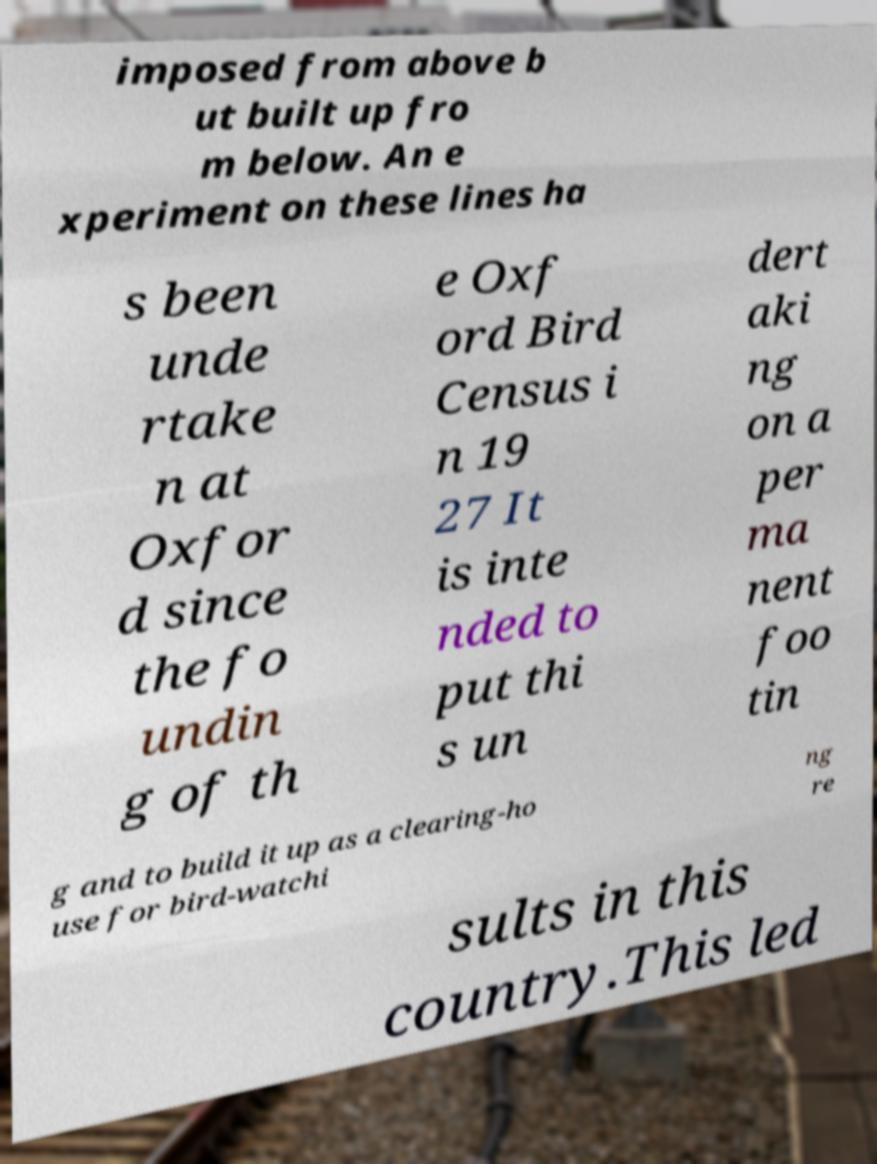Could you extract and type out the text from this image? imposed from above b ut built up fro m below. An e xperiment on these lines ha s been unde rtake n at Oxfor d since the fo undin g of th e Oxf ord Bird Census i n 19 27 It is inte nded to put thi s un dert aki ng on a per ma nent foo tin g and to build it up as a clearing-ho use for bird-watchi ng re sults in this country.This led 